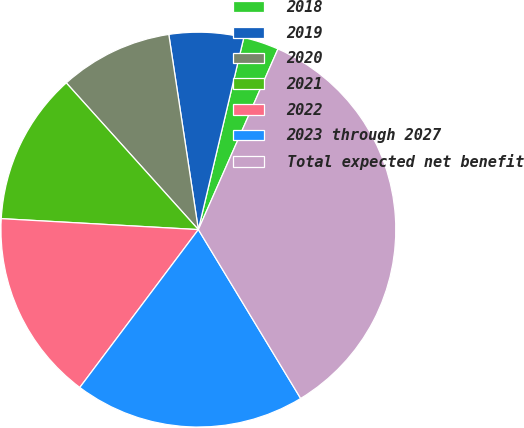Convert chart. <chart><loc_0><loc_0><loc_500><loc_500><pie_chart><fcel>2018<fcel>2019<fcel>2020<fcel>2021<fcel>2022<fcel>2023 through 2027<fcel>Total expected net benefit<nl><fcel>2.91%<fcel>6.09%<fcel>9.27%<fcel>12.45%<fcel>15.63%<fcel>18.92%<fcel>34.72%<nl></chart> 